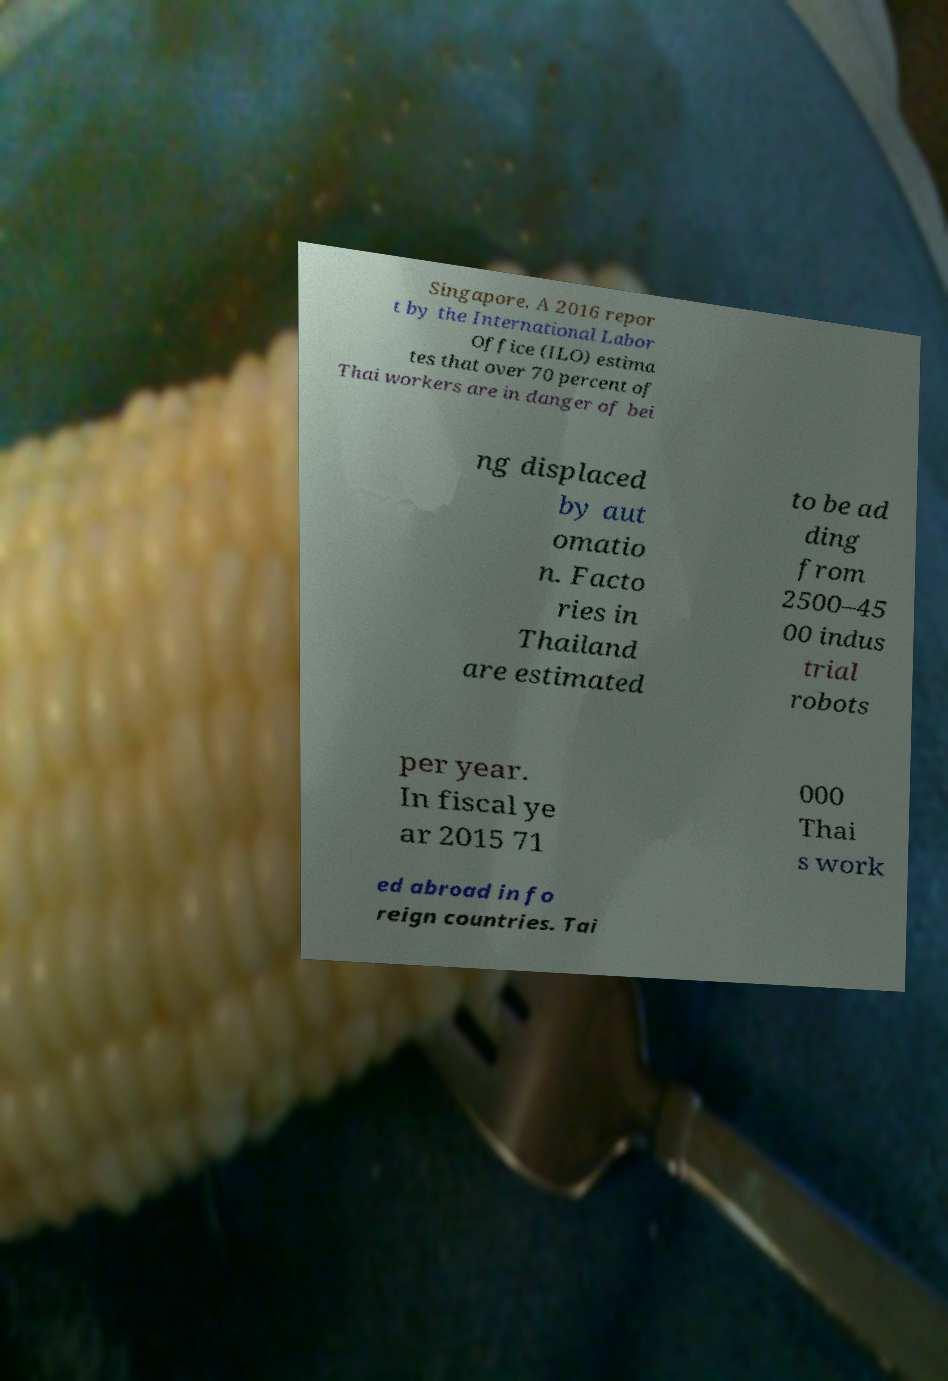There's text embedded in this image that I need extracted. Can you transcribe it verbatim? Singapore. A 2016 repor t by the International Labor Office (ILO) estima tes that over 70 percent of Thai workers are in danger of bei ng displaced by aut omatio n. Facto ries in Thailand are estimated to be ad ding from 2500–45 00 indus trial robots per year. In fiscal ye ar 2015 71 000 Thai s work ed abroad in fo reign countries. Tai 